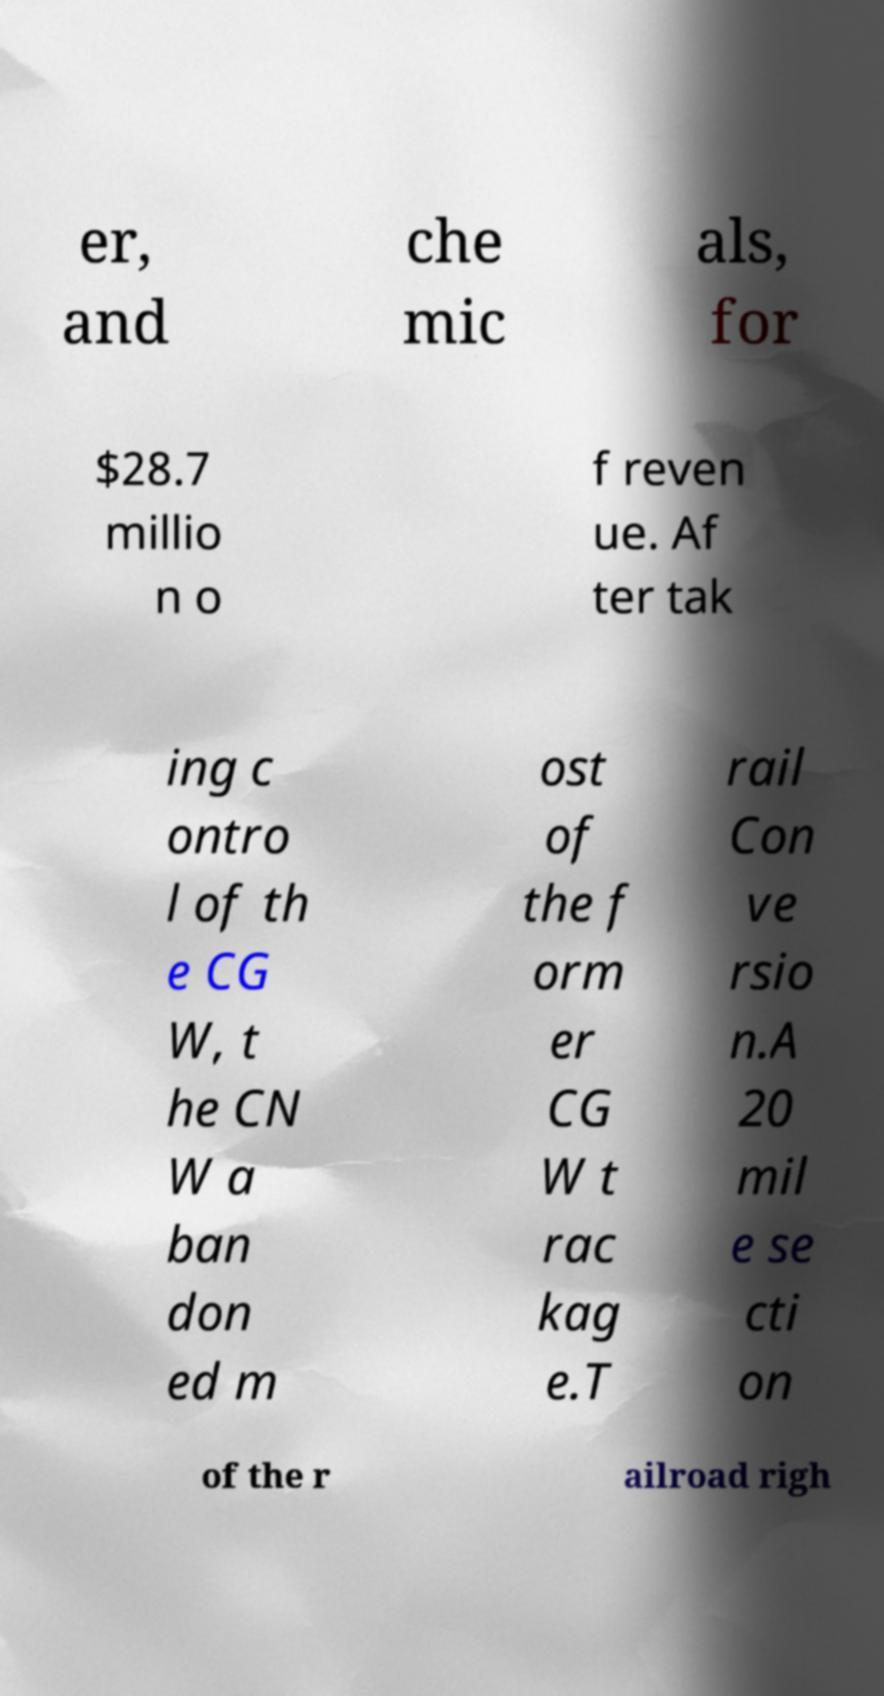Could you extract and type out the text from this image? er, and che mic als, for $28.7 millio n o f reven ue. Af ter tak ing c ontro l of th e CG W, t he CN W a ban don ed m ost of the f orm er CG W t rac kag e.T rail Con ve rsio n.A 20 mil e se cti on of the r ailroad righ 